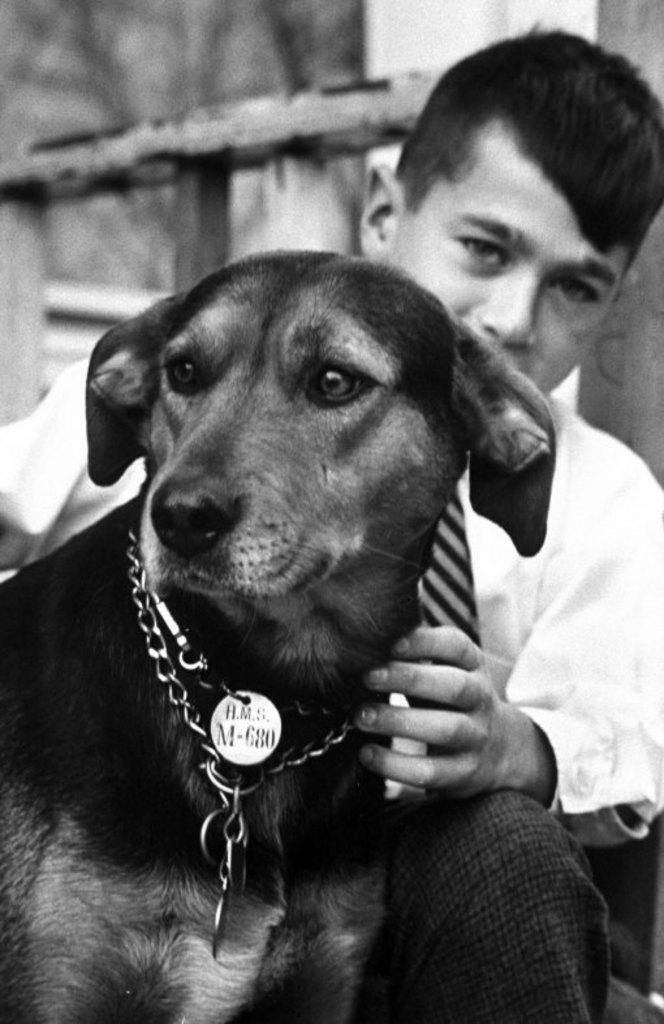Can you describe this image briefly? By seeing this image we can say that this is a black and white picture and in the picture, we can say that there is a boy touching the dog. 